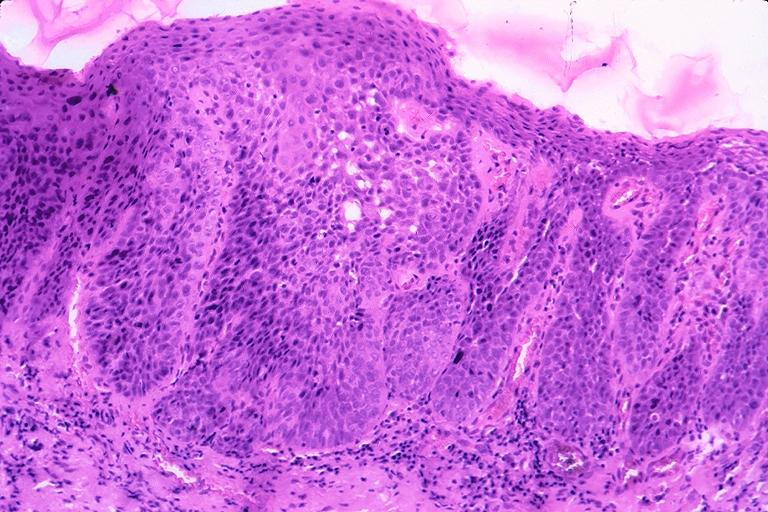s oral present?
Answer the question using a single word or phrase. Yes 